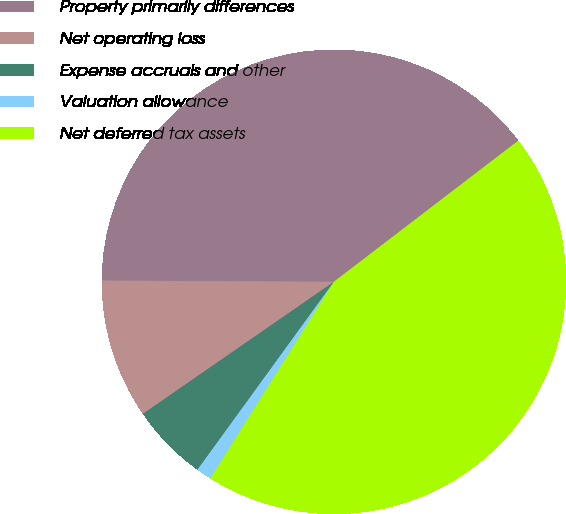Convert chart. <chart><loc_0><loc_0><loc_500><loc_500><pie_chart><fcel>Property primarily differences<fcel>Net operating loss<fcel>Expense accruals and other<fcel>Valuation allowance<fcel>Net deferred tax assets<nl><fcel>39.52%<fcel>9.71%<fcel>5.38%<fcel>1.06%<fcel>44.33%<nl></chart> 